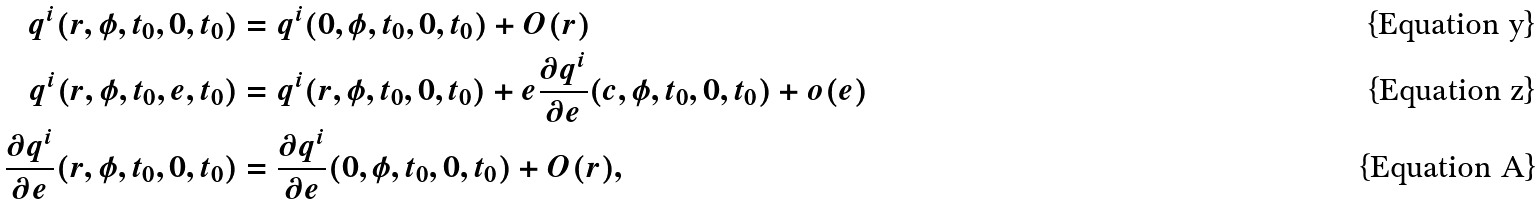<formula> <loc_0><loc_0><loc_500><loc_500>q ^ { i } ( r , \phi , t _ { 0 } , 0 , t _ { 0 } ) & = q ^ { i } ( 0 , \phi , t _ { 0 } , 0 , t _ { 0 } ) + O ( r ) \\ q ^ { i } ( r , \phi , t _ { 0 } , e , t _ { 0 } ) & = q ^ { i } ( r , \phi , t _ { 0 } , 0 , t _ { 0 } ) + e \frac { \partial q ^ { i } } { \partial e } ( c , \phi , t _ { 0 } , 0 , t _ { 0 } ) + o ( e ) \\ \frac { \partial q ^ { i } } { \partial e } ( r , \phi , t _ { 0 } , 0 , t _ { 0 } ) & = \frac { \partial q ^ { i } } { \partial e } ( 0 , \phi , t _ { 0 } , 0 , t _ { 0 } ) + O ( r ) ,</formula> 